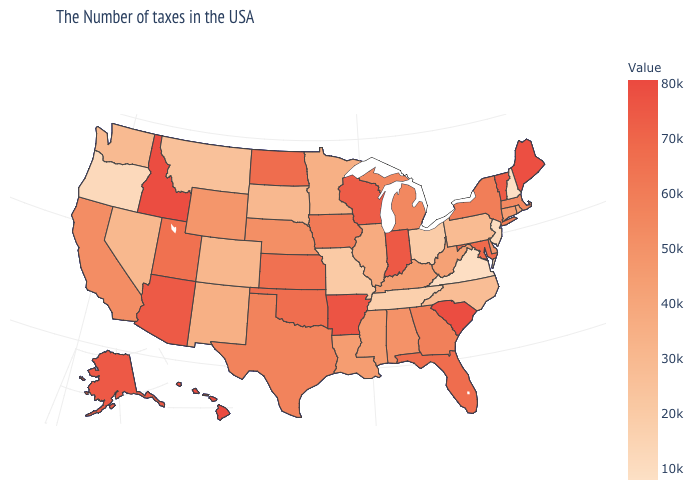Among the states that border North Carolina , does Virginia have the lowest value?
Concise answer only. Yes. Among the states that border Ohio , does Pennsylvania have the lowest value?
Quick response, please. Yes. Among the states that border New Jersey , does Pennsylvania have the highest value?
Be succinct. No. Is the legend a continuous bar?
Short answer required. Yes. Does South Carolina have the highest value in the South?
Be succinct. Yes. Does Maryland have the highest value in the USA?
Be succinct. No. 